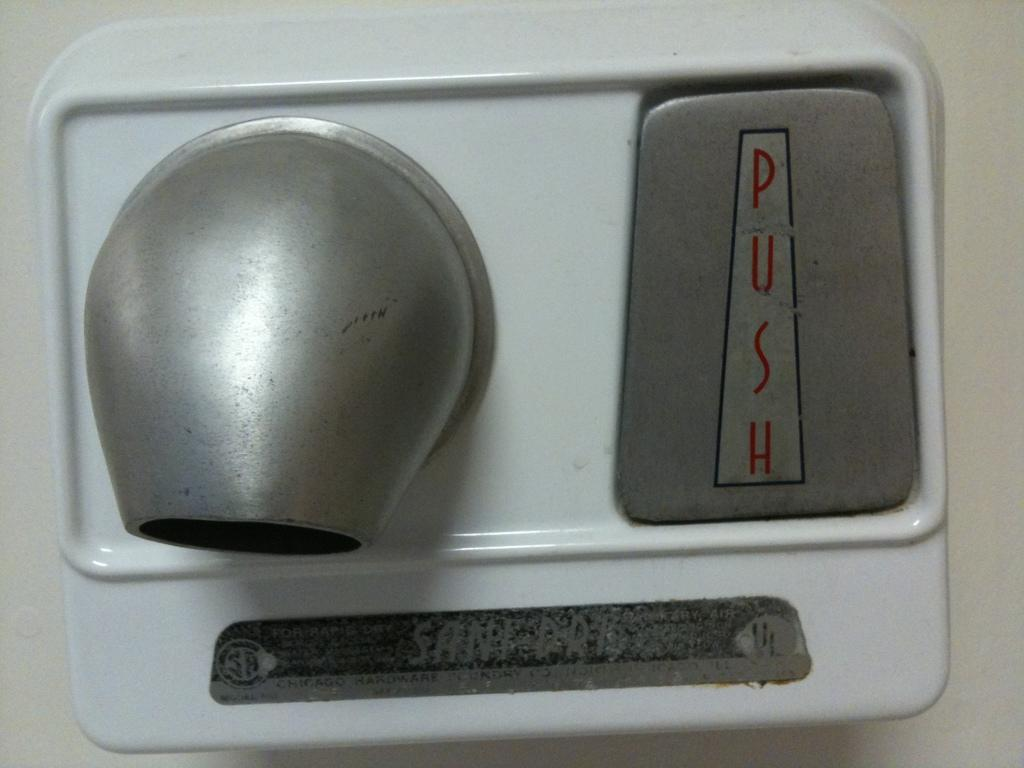<image>
Write a terse but informative summary of the picture. An old hand dryer says push in red letters. 